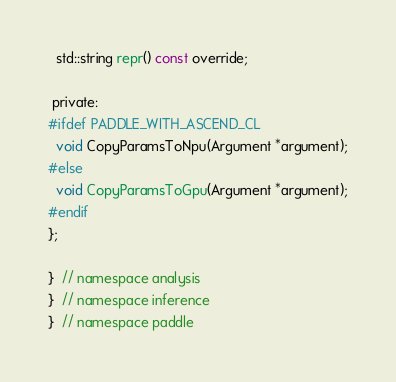Convert code to text. <code><loc_0><loc_0><loc_500><loc_500><_C_>  std::string repr() const override;

 private:
#ifdef PADDLE_WITH_ASCEND_CL
  void CopyParamsToNpu(Argument *argument);
#else
  void CopyParamsToGpu(Argument *argument);
#endif
};

}  // namespace analysis
}  // namespace inference
}  // namespace paddle
</code> 